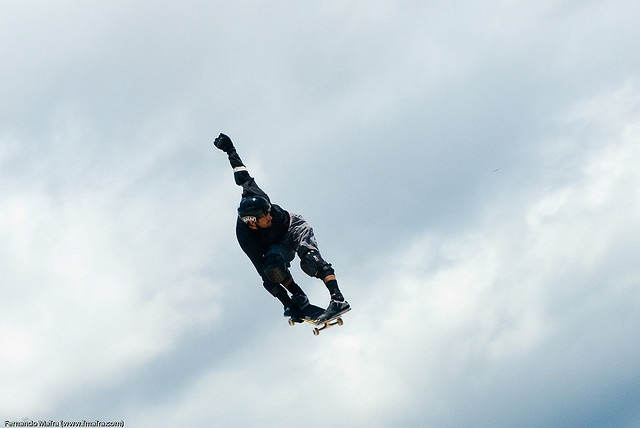Describe the objects in this image and their specific colors. I can see people in lightgray, black, gray, and lightblue tones and skateboard in lightgray, black, gray, and darkgray tones in this image. 